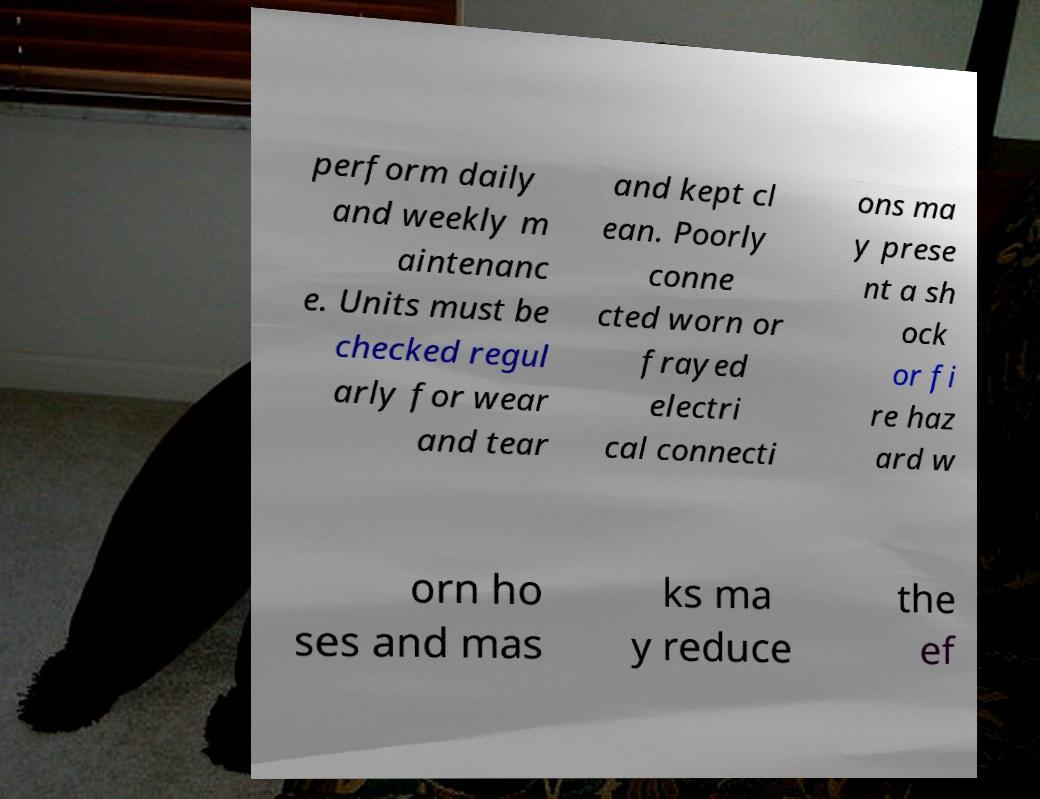Could you assist in decoding the text presented in this image and type it out clearly? perform daily and weekly m aintenanc e. Units must be checked regul arly for wear and tear and kept cl ean. Poorly conne cted worn or frayed electri cal connecti ons ma y prese nt a sh ock or fi re haz ard w orn ho ses and mas ks ma y reduce the ef 